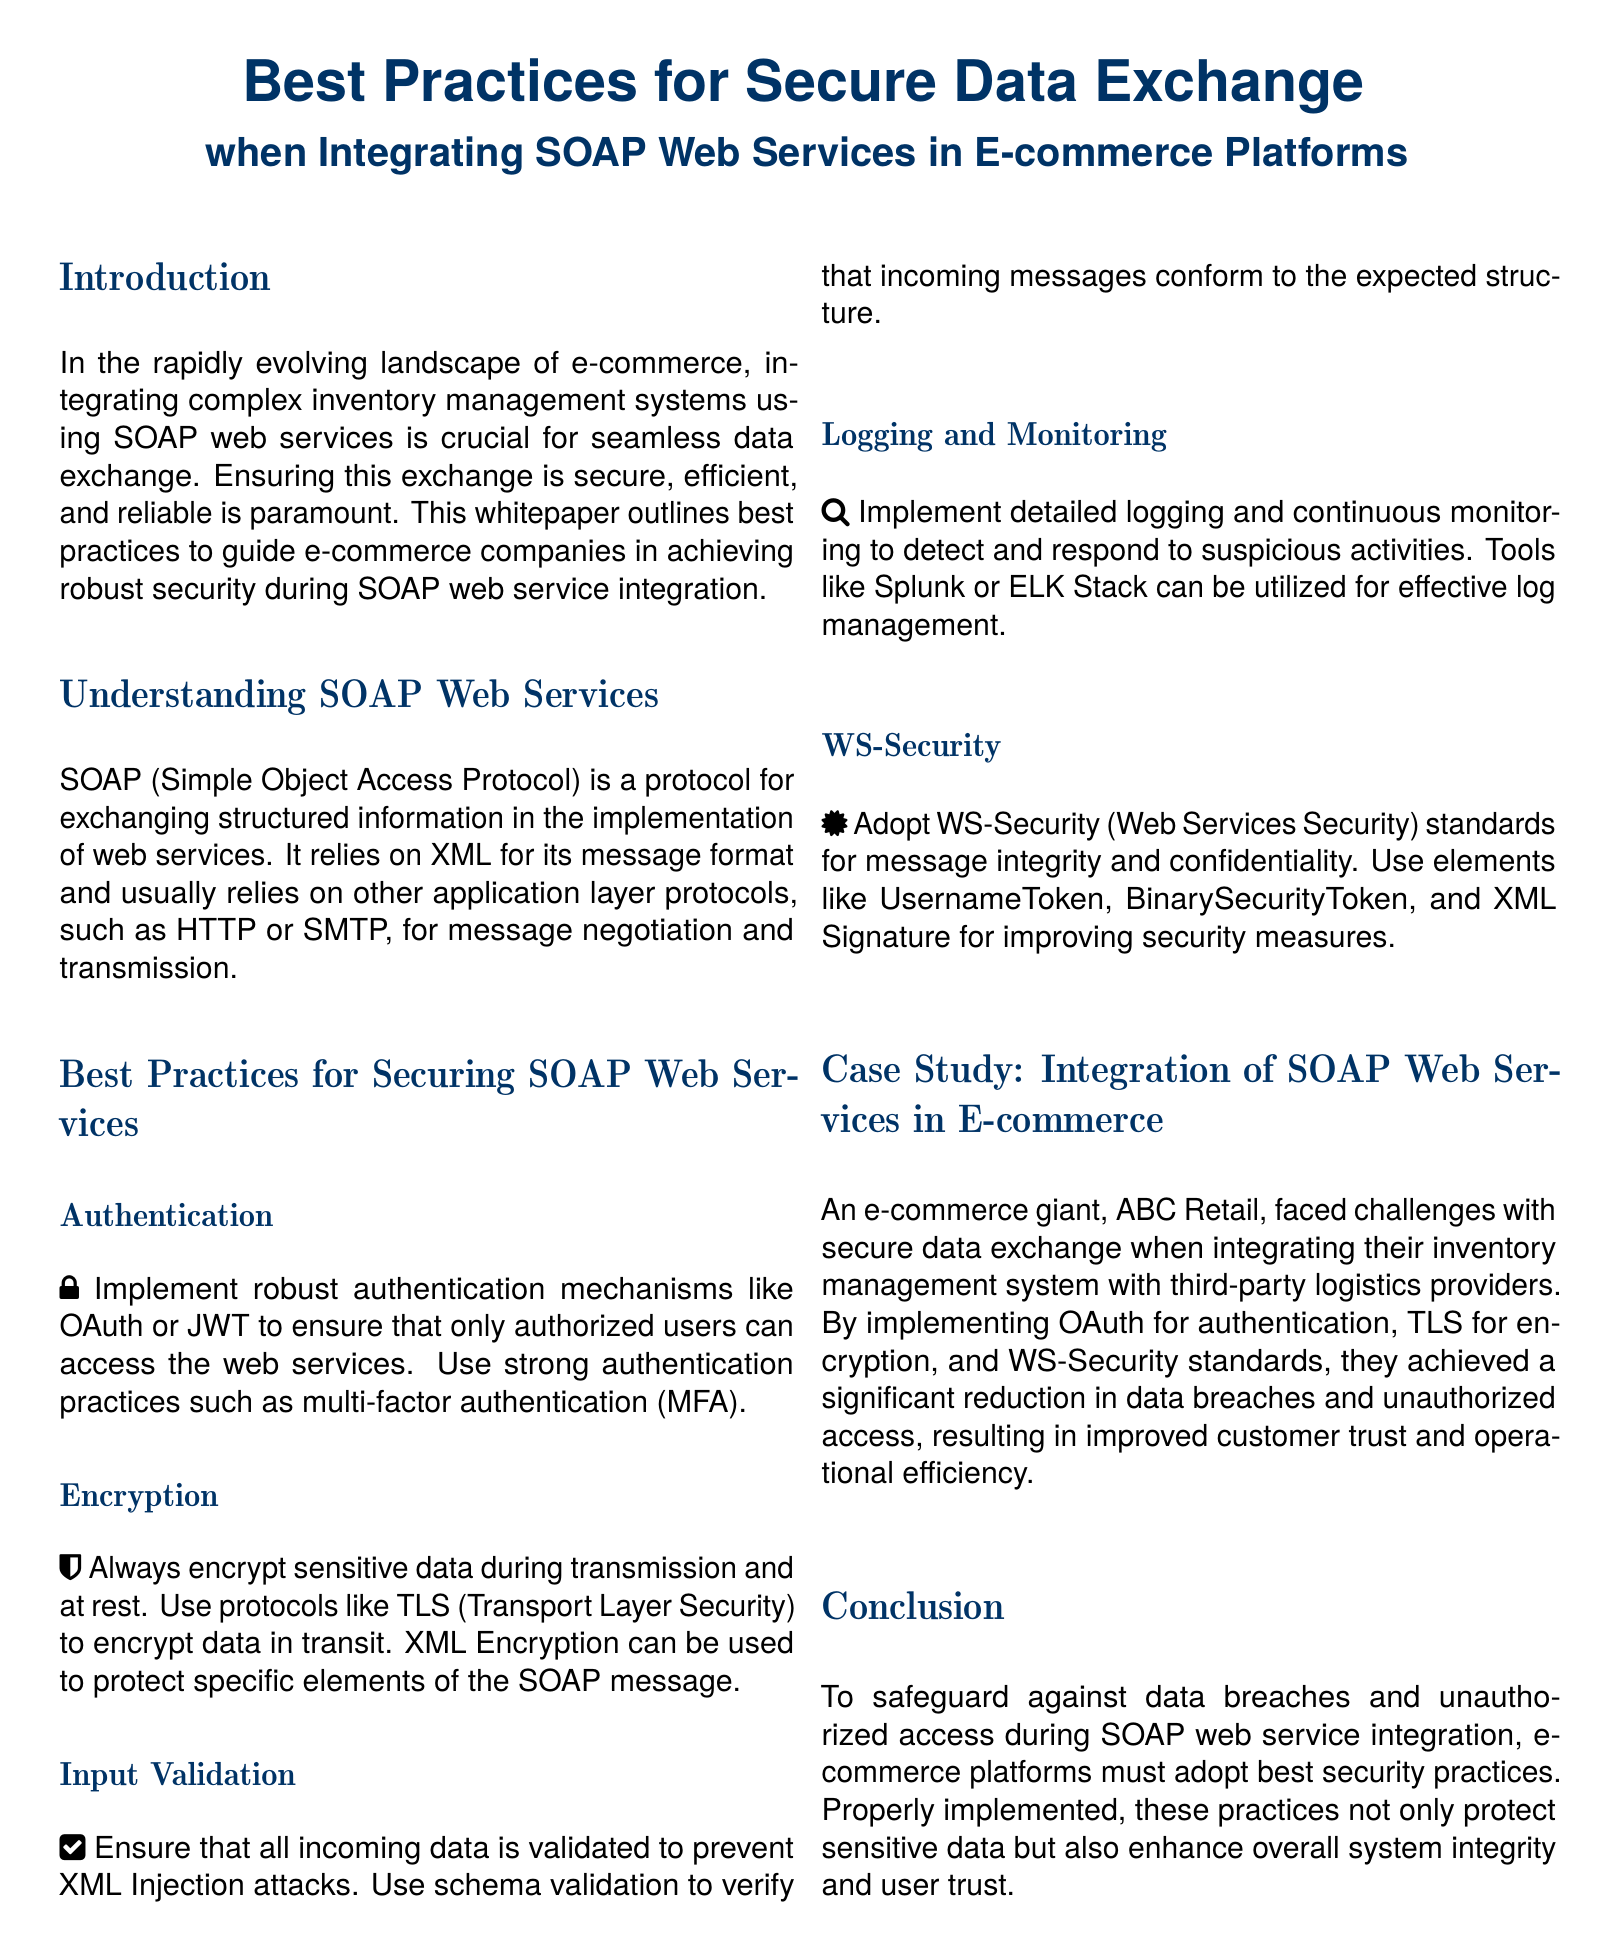What is the title of the document? The title is the main heading visible at the top of the document.
Answer: Best Practices for Secure Data Exchange when Integrating SOAP Web Services in E-commerce Platforms What protocol does SOAP rely on for message transmission? The document states that SOAP generally relies on application layer protocols for transmission.
Answer: HTTP or SMTP What practice should be implemented for authentication? The document specifies the authentication mechanisms recommended to secure access.
Answer: OAuth or JWT What should be used to encrypt data during transmission? The document mentions specific protocols to ensure data is encrypted while being sent.
Answer: TLS What is one of the tools mentioned for logging and monitoring? The document lists tools that can help with log management for monitoring suspicious activities.
Answer: Splunk What security standard is recommended for message integrity? The document discusses a specific standard to be used for enhancing message security.
Answer: WS-Security What was the name of the e-commerce giant mentioned in the case study? The document includes a company name as an example within the case study.
Answer: ABC Retail What benefit did ABC Retail achieve by implementing these security practices? The document highlights a positive outcome from good security implementation.
Answer: Improved customer trust and operational efficiency 